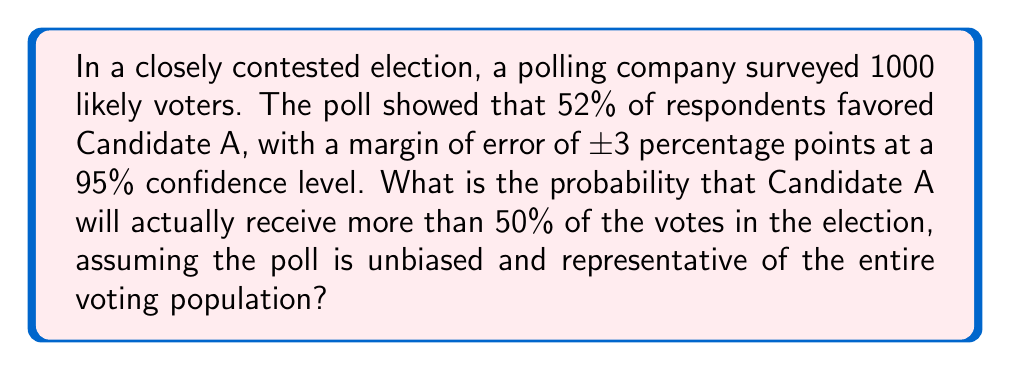Can you solve this math problem? Let's approach this step-by-step:

1) First, we need to understand what the margin of error means. With a 95% confidence level and a ±3 percentage point margin of error, we can say that there's a 95% chance that the true proportion of voters favoring Candidate A is within the range of 49% to 55% (52% ± 3%).

2) We want to find the probability that Candidate A will receive more than 50% of the votes. This is equivalent to finding the probability that the true proportion is greater than 50%, given our poll results.

3) To calculate this, we need to use the normal distribution. The Central Limit Theorem tells us that for large sample sizes, the sampling distribution of the sample proportion is approximately normal.

4) The standard error of the sample proportion is given by:

   $$SE = \sqrt{\frac{p(1-p)}{n}}$$

   where $p$ is the sample proportion and $n$ is the sample size.

5) In this case, $p = 0.52$ and $n = 1000$. So:

   $$SE = \sqrt{\frac{0.52(1-0.52)}{1000}} = 0.0158$$

6) The z-score for 50% (our threshold) is:

   $$z = \frac{0.50 - 0.52}{0.0158} = -1.27$$

7) We want the probability that the true proportion is greater than 50%, which is equivalent to the area to the right of z = -1.27 on a standard normal distribution.

8) Using a z-table or calculator, we find that the area to the right of z = -1.27 is approximately 0.898.

Therefore, based on this poll, there is about an 89.8% chance that Candidate A will receive more than 50% of the votes in the actual election.
Answer: 89.8% 